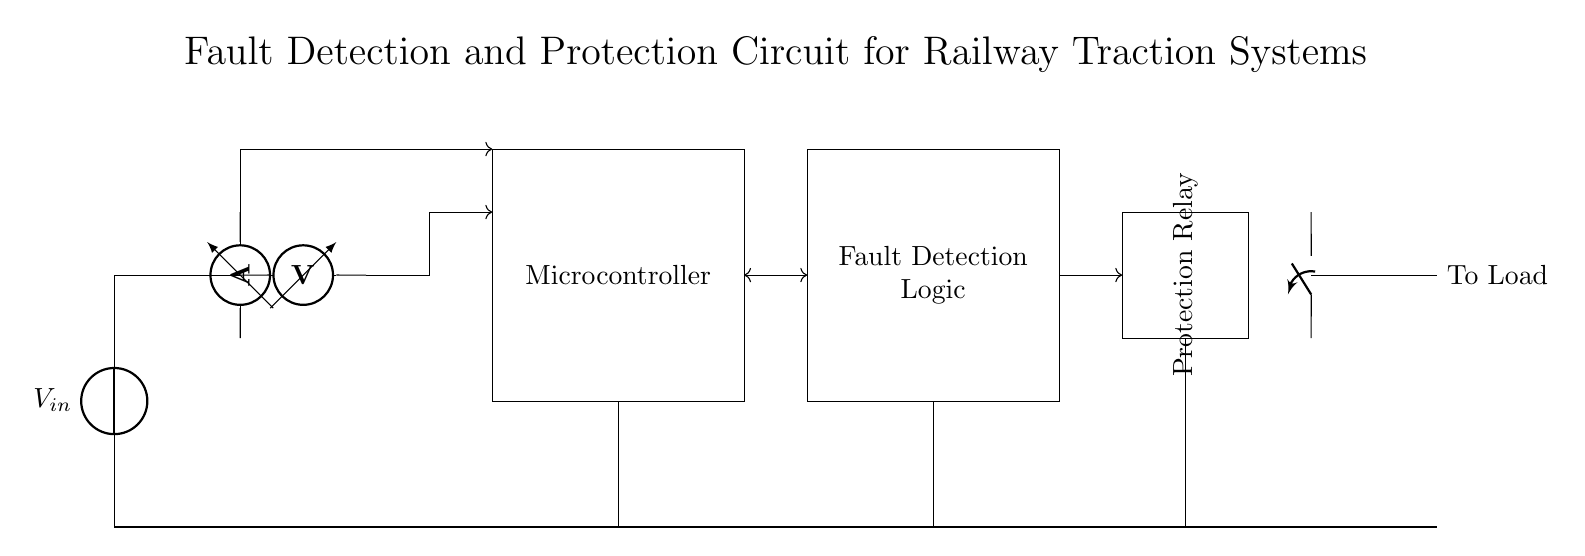What is the type of the main power supply in this circuit? The main power supply is indicated by the symbol representing voltage source, which typically delivers a consistent voltage to the circuit.
Answer: Voltage source What component is used to measure the current in this circuit? The circuit includes an ammeter symbol placed to measure the current flowing through a specific branch, which is clearly indicated in the diagram.
Answer: Ammeter How many ADC inputs are there connected to the microcontroller? The diagram shows two input connections from different sensors to the microcontroller, suggesting there are two ADC inputs.
Answer: Two What does the protection relay do in this circuit? The protection relay analyzes signals from the fault detection logic and provides control over the circuit breaker, enabling safety features by disconnecting the circuit when faults are detected.
Answer: Disconnect Which component is responsible for fault detection in the circuit? The fault detection logic section in the diagram is identified to perform this function, linking the microcontroller to the protection relay.
Answer: Fault Detection Logic What voltage is the circuit designed to handle; is it specified in the diagram? The circuit does not explicitly specify a voltage value; it only shows a general voltage input symbol. Thus, no numeric value can be derived.
Answer: Not specified What is the function of the circuit breaker in this circuit? The circuit breaker is represented as an opening switch, indicating it opens the circuit to protect against excessive current or fault conditions, preventing damage.
Answer: Protection 